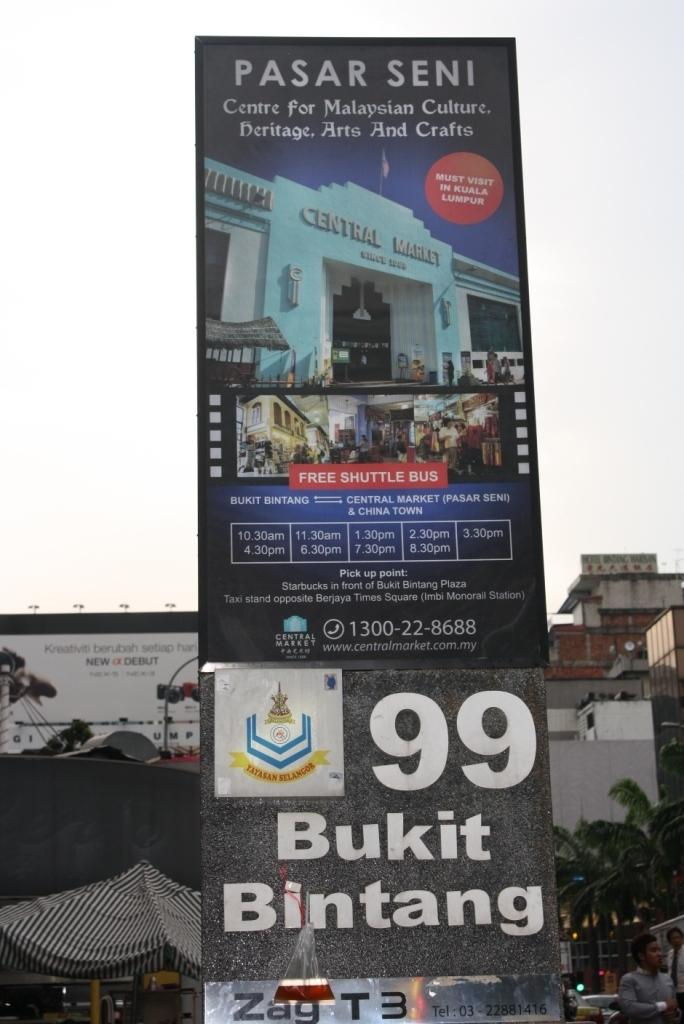<image>
Create a compact narrative representing the image presented. An event in a big city with a billboard sign that reads Bukit Bintang. 